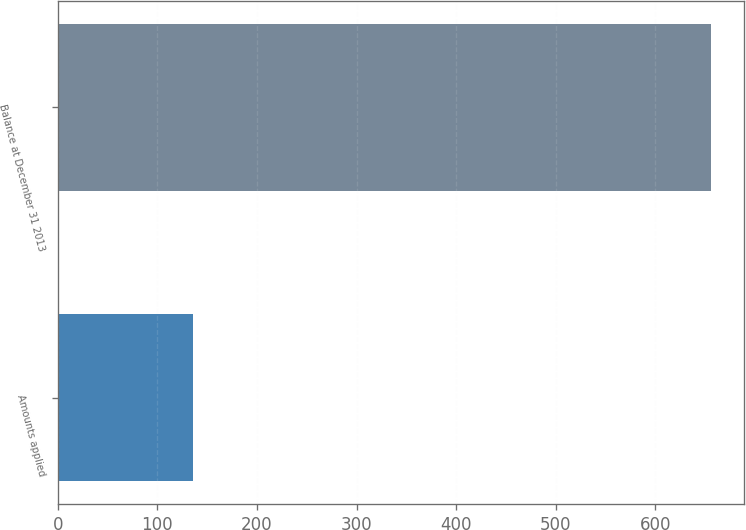<chart> <loc_0><loc_0><loc_500><loc_500><bar_chart><fcel>Amounts applied<fcel>Balance at December 31 2013<nl><fcel>136<fcel>656<nl></chart> 